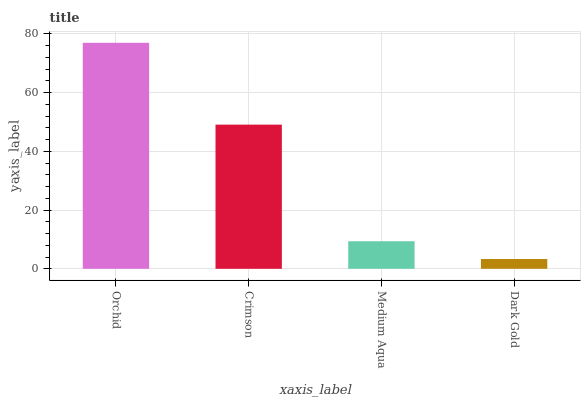Is Dark Gold the minimum?
Answer yes or no. Yes. Is Orchid the maximum?
Answer yes or no. Yes. Is Crimson the minimum?
Answer yes or no. No. Is Crimson the maximum?
Answer yes or no. No. Is Orchid greater than Crimson?
Answer yes or no. Yes. Is Crimson less than Orchid?
Answer yes or no. Yes. Is Crimson greater than Orchid?
Answer yes or no. No. Is Orchid less than Crimson?
Answer yes or no. No. Is Crimson the high median?
Answer yes or no. Yes. Is Medium Aqua the low median?
Answer yes or no. Yes. Is Dark Gold the high median?
Answer yes or no. No. Is Dark Gold the low median?
Answer yes or no. No. 